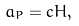Convert formula to latex. <formula><loc_0><loc_0><loc_500><loc_500>a _ { P } = c H ,</formula> 